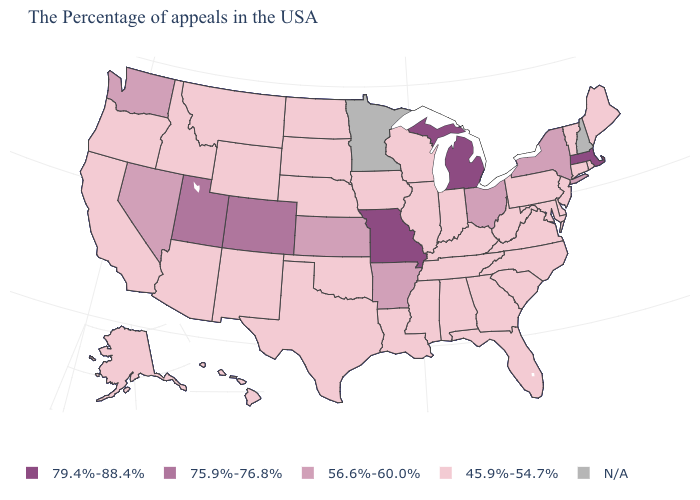Does Kansas have the lowest value in the USA?
Write a very short answer. No. Name the states that have a value in the range N/A?
Keep it brief. New Hampshire, Minnesota. What is the lowest value in the USA?
Short answer required. 45.9%-54.7%. What is the lowest value in the USA?
Concise answer only. 45.9%-54.7%. What is the value of Vermont?
Concise answer only. 45.9%-54.7%. What is the value of Hawaii?
Keep it brief. 45.9%-54.7%. Among the states that border Colorado , which have the lowest value?
Keep it brief. Nebraska, Oklahoma, Wyoming, New Mexico, Arizona. Among the states that border Utah , does Colorado have the highest value?
Be succinct. Yes. Name the states that have a value in the range 75.9%-76.8%?
Quick response, please. Colorado, Utah. What is the value of Illinois?
Be succinct. 45.9%-54.7%. Does Massachusetts have the highest value in the Northeast?
Give a very brief answer. Yes. What is the lowest value in the South?
Give a very brief answer. 45.9%-54.7%. Name the states that have a value in the range 79.4%-88.4%?
Short answer required. Massachusetts, Michigan, Missouri. 